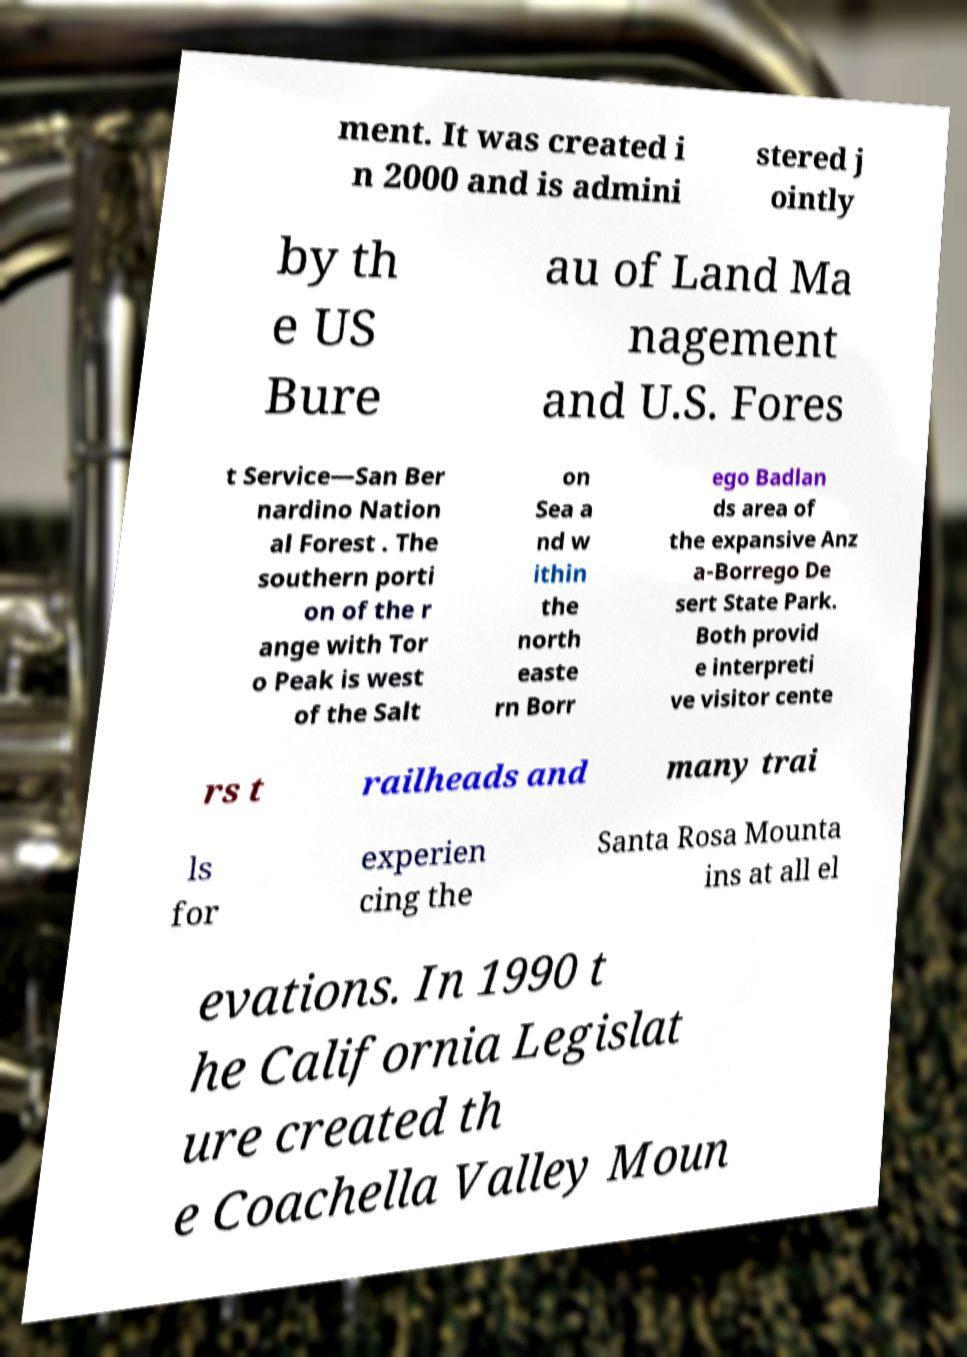There's text embedded in this image that I need extracted. Can you transcribe it verbatim? ment. It was created i n 2000 and is admini stered j ointly by th e US Bure au of Land Ma nagement and U.S. Fores t Service—San Ber nardino Nation al Forest . The southern porti on of the r ange with Tor o Peak is west of the Salt on Sea a nd w ithin the north easte rn Borr ego Badlan ds area of the expansive Anz a-Borrego De sert State Park. Both provid e interpreti ve visitor cente rs t railheads and many trai ls for experien cing the Santa Rosa Mounta ins at all el evations. In 1990 t he California Legislat ure created th e Coachella Valley Moun 